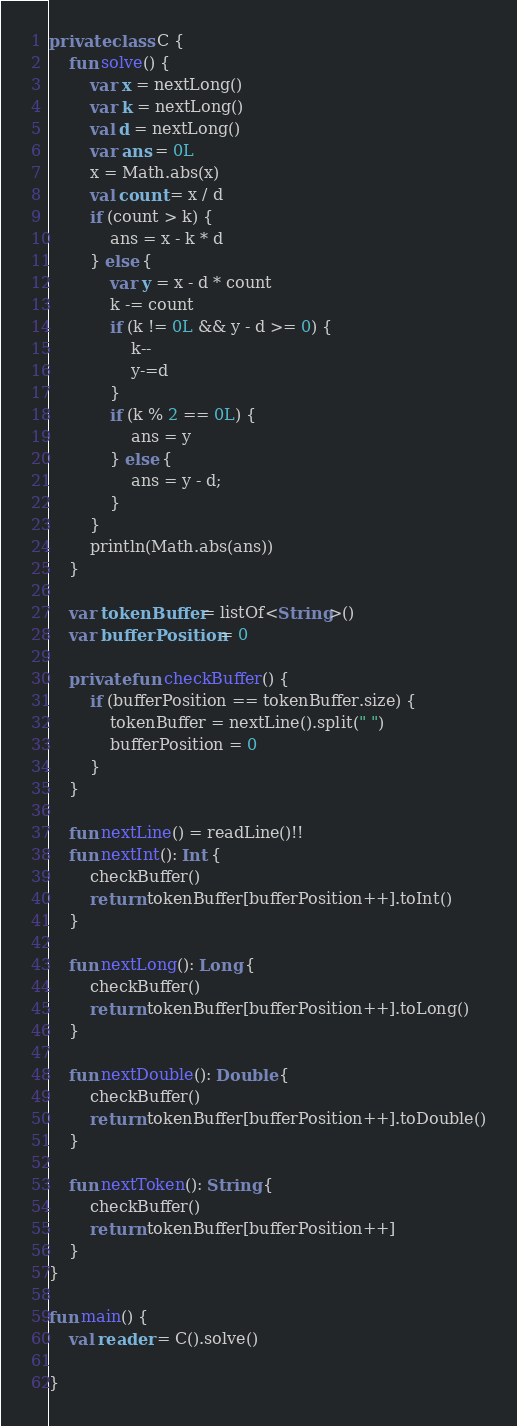<code> <loc_0><loc_0><loc_500><loc_500><_Kotlin_>private class C {
    fun solve() {
        var x = nextLong()
        var k = nextLong()
        val d = nextLong()
        var ans = 0L
        x = Math.abs(x)
        val count = x / d
        if (count > k) {
            ans = x - k * d
        } else {
            var y = x - d * count
            k -= count
            if (k != 0L && y - d >= 0) {
                k--
                y-=d
            }
            if (k % 2 == 0L) {
                ans = y
            } else {
                ans = y - d;
            }
        }
        println(Math.abs(ans))
    }

    var tokenBuffer = listOf<String>()
    var bufferPosition = 0

    private fun checkBuffer() {
        if (bufferPosition == tokenBuffer.size) {
            tokenBuffer = nextLine().split(" ")
            bufferPosition = 0
        }
    }

    fun nextLine() = readLine()!!
    fun nextInt(): Int {
        checkBuffer()
        return tokenBuffer[bufferPosition++].toInt()
    }

    fun nextLong(): Long {
        checkBuffer()
        return tokenBuffer[bufferPosition++].toLong()
    }

    fun nextDouble(): Double {
        checkBuffer()
        return tokenBuffer[bufferPosition++].toDouble()
    }

    fun nextToken(): String {
        checkBuffer()
        return tokenBuffer[bufferPosition++]
    }
}

fun main() {
    val reader = C().solve()

}
</code> 